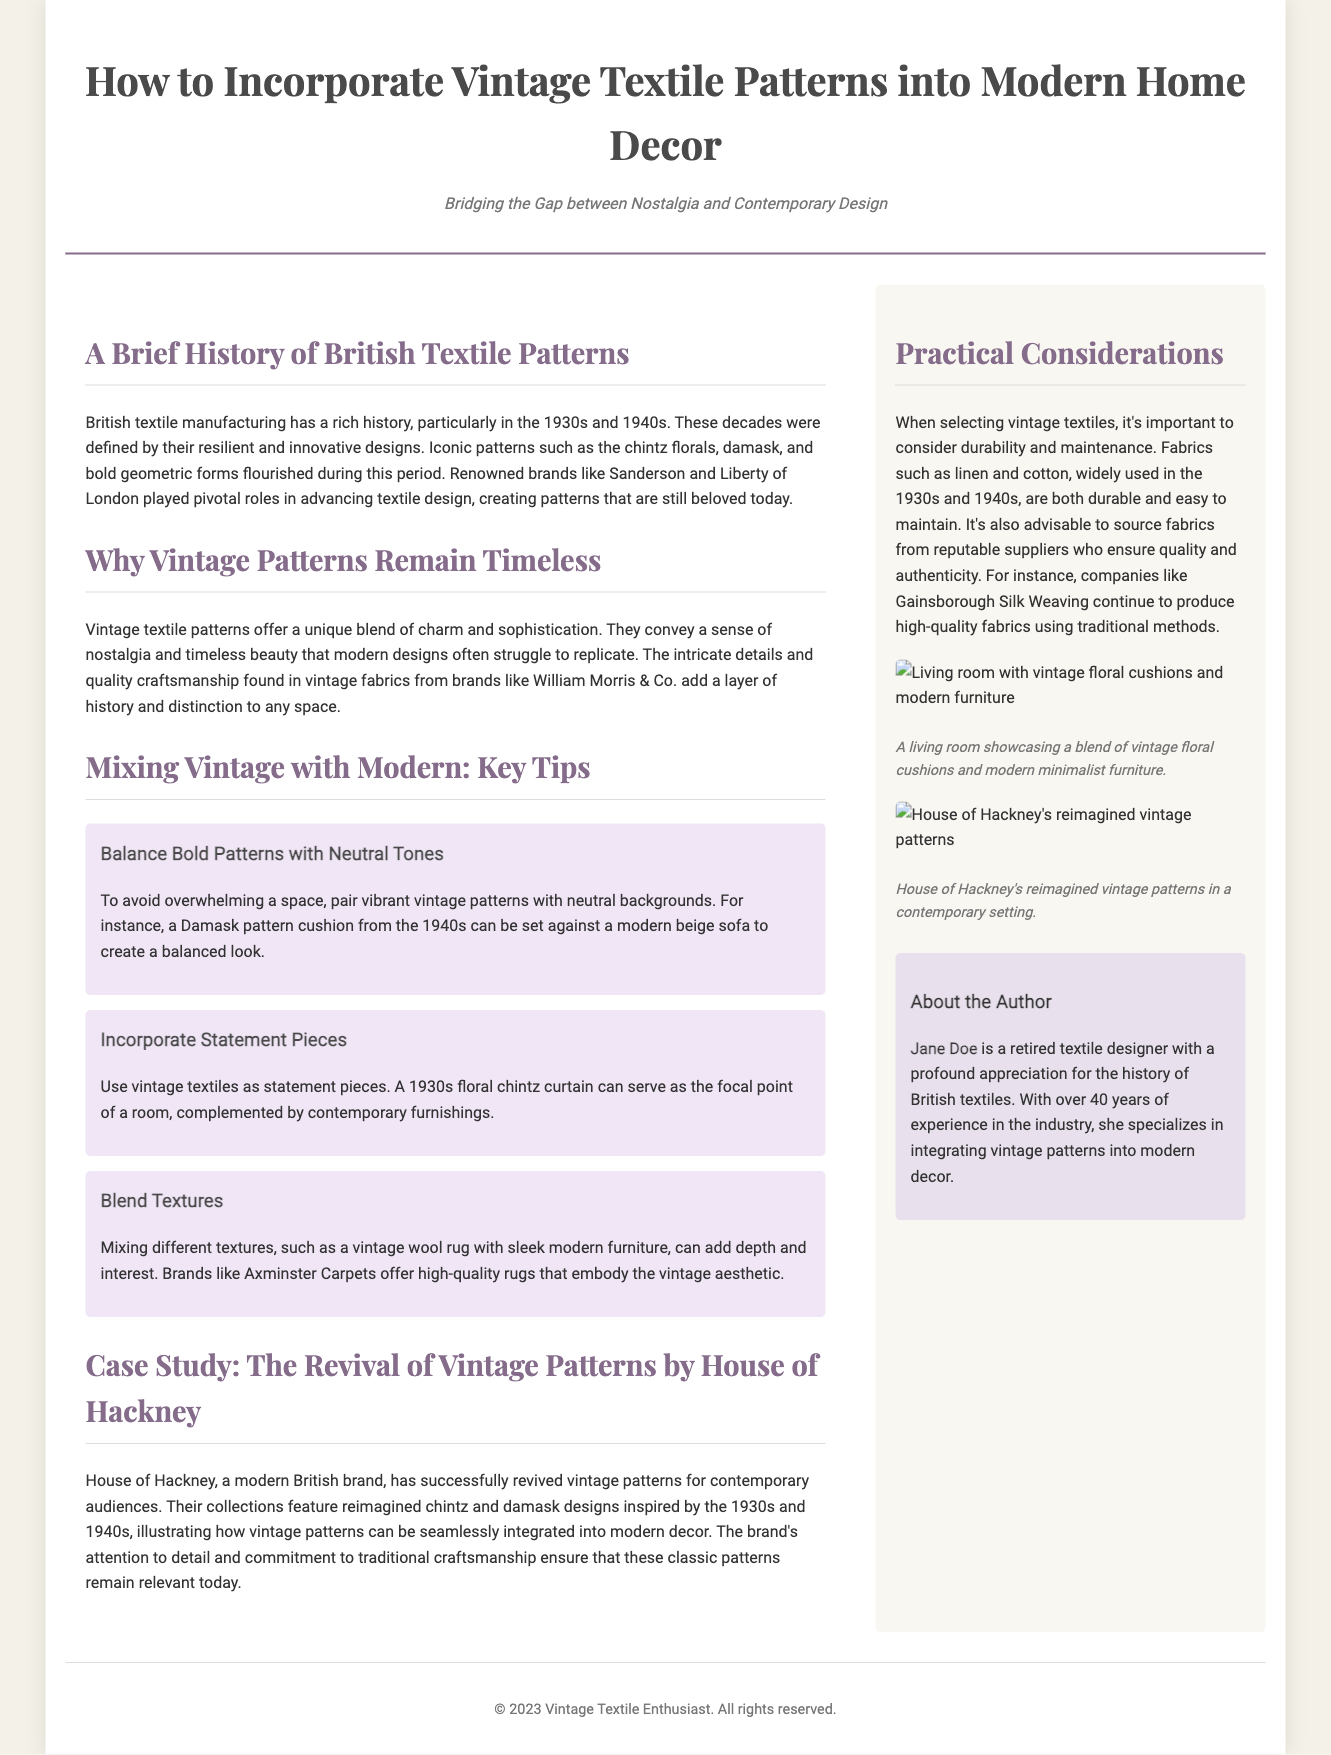What is the title of the article? The title of the article is clearly stated at the top of the document in a prominent manner.
Answer: How to Incorporate Vintage Textile Patterns into Modern Home Decor Who is the author of the article? The author is introduced in the author bio section, providing her name and expertise related to the subject.
Answer: Jane Doe What years are highlighted in the history of British textile patterns? The years mentioned in the context of British textile manufacturing history are specified to showcase the focus of the article.
Answer: 1930s and 1940s What type of textiles does House of Hackney feature? The specific textiles mentioned in relation to House of Hackney show their dedication to a certain aesthetic.
Answer: Reimagined chintz and damask designs What should be mixed with vintage textiles to create balance? The article provides tips on how to effectively incorporate vintage patterns into modern decor, detailing specific complementary elements.
Answer: Neutral tones Which brand is known for high-quality rugs embodying the vintage aesthetic? The document references a particular brand noted for its quality vintage-style rugs.
Answer: Axminster Carpets What fabric types from the 1930s and 1940s are mentioned for durability? The article mentions specific fabric types that are characterized by durability and ease of maintenance in the context of vintage textiles.
Answer: Linen and cotton What is a key benefit of using vintage textile patterns in modern decor? The article discusses the impact that vintage patterns bring to contemporary spaces, providing a comparison to modern designs.
Answer: A sense of nostalgia and timeless beauty 